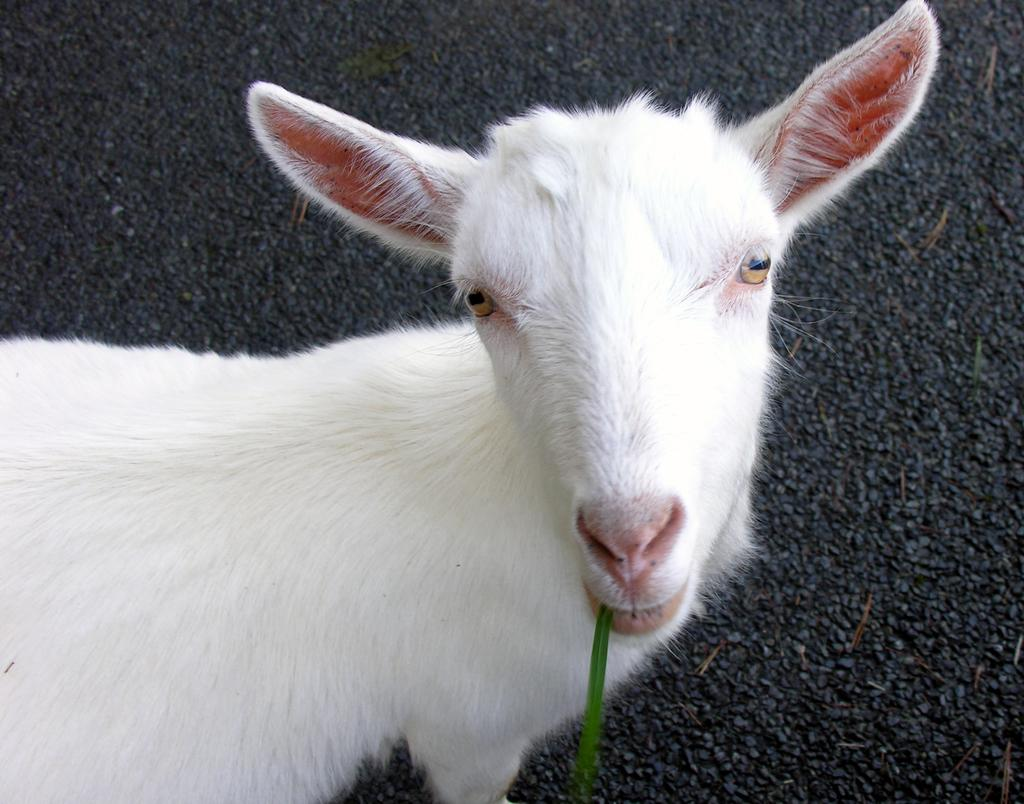What type of animal is present in the image? There is an animal in the image, but its specific type cannot be determined from the provided facts. What can be seen in the background of the image? There is a road visible in the background of the image. What type of badge is the animal wearing in the image? There is no mention of a badge in the image, and therefore no such item can be observed. Can you recite the verse that is written on the animal's collar in the image? There is no mention of a collar or any verse written on it in the image. 